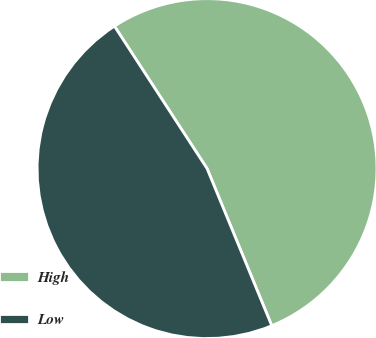Convert chart to OTSL. <chart><loc_0><loc_0><loc_500><loc_500><pie_chart><fcel>High<fcel>Low<nl><fcel>52.96%<fcel>47.04%<nl></chart> 